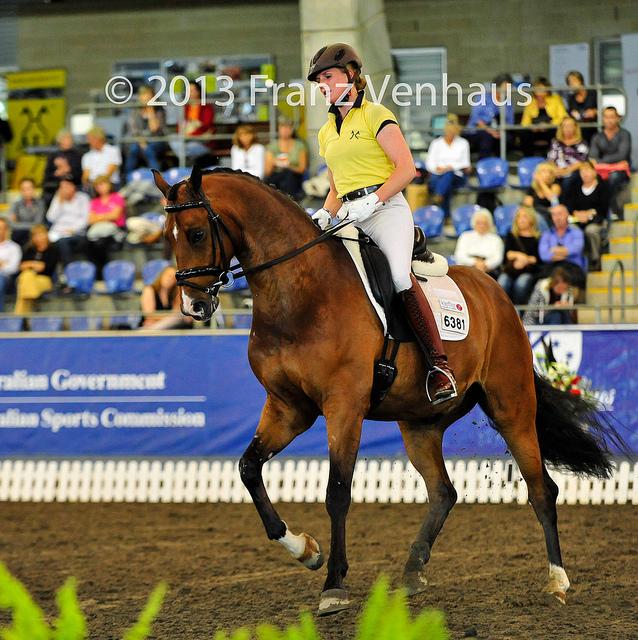What is the horse doing?
Be succinct. Running. What color is the horse?
Give a very brief answer. Brown. How many horses are there?
Short answer required. 1. What year is it?
Be succinct. 2013. What two colors make up the riders helmet?
Keep it brief. Brown and black. What are the horse numbers?
Be succinct. 6381. What is it called when the horse moves with high knees, as shown here?
Short answer required. Trotting. 